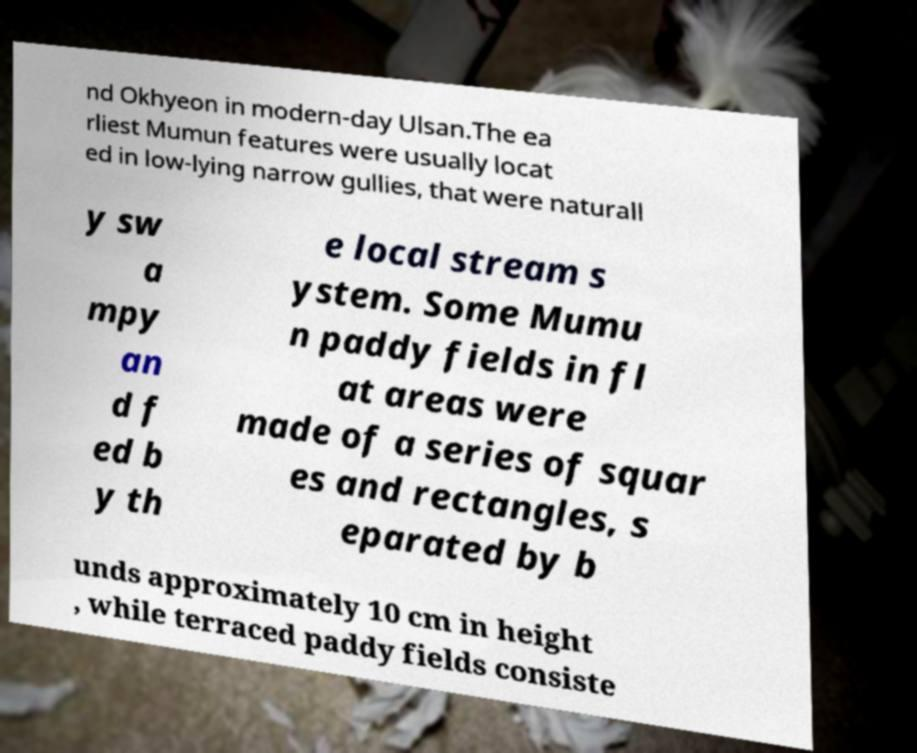Can you accurately transcribe the text from the provided image for me? nd Okhyeon in modern-day Ulsan.The ea rliest Mumun features were usually locat ed in low-lying narrow gullies, that were naturall y sw a mpy an d f ed b y th e local stream s ystem. Some Mumu n paddy fields in fl at areas were made of a series of squar es and rectangles, s eparated by b unds approximately 10 cm in height , while terraced paddy fields consiste 